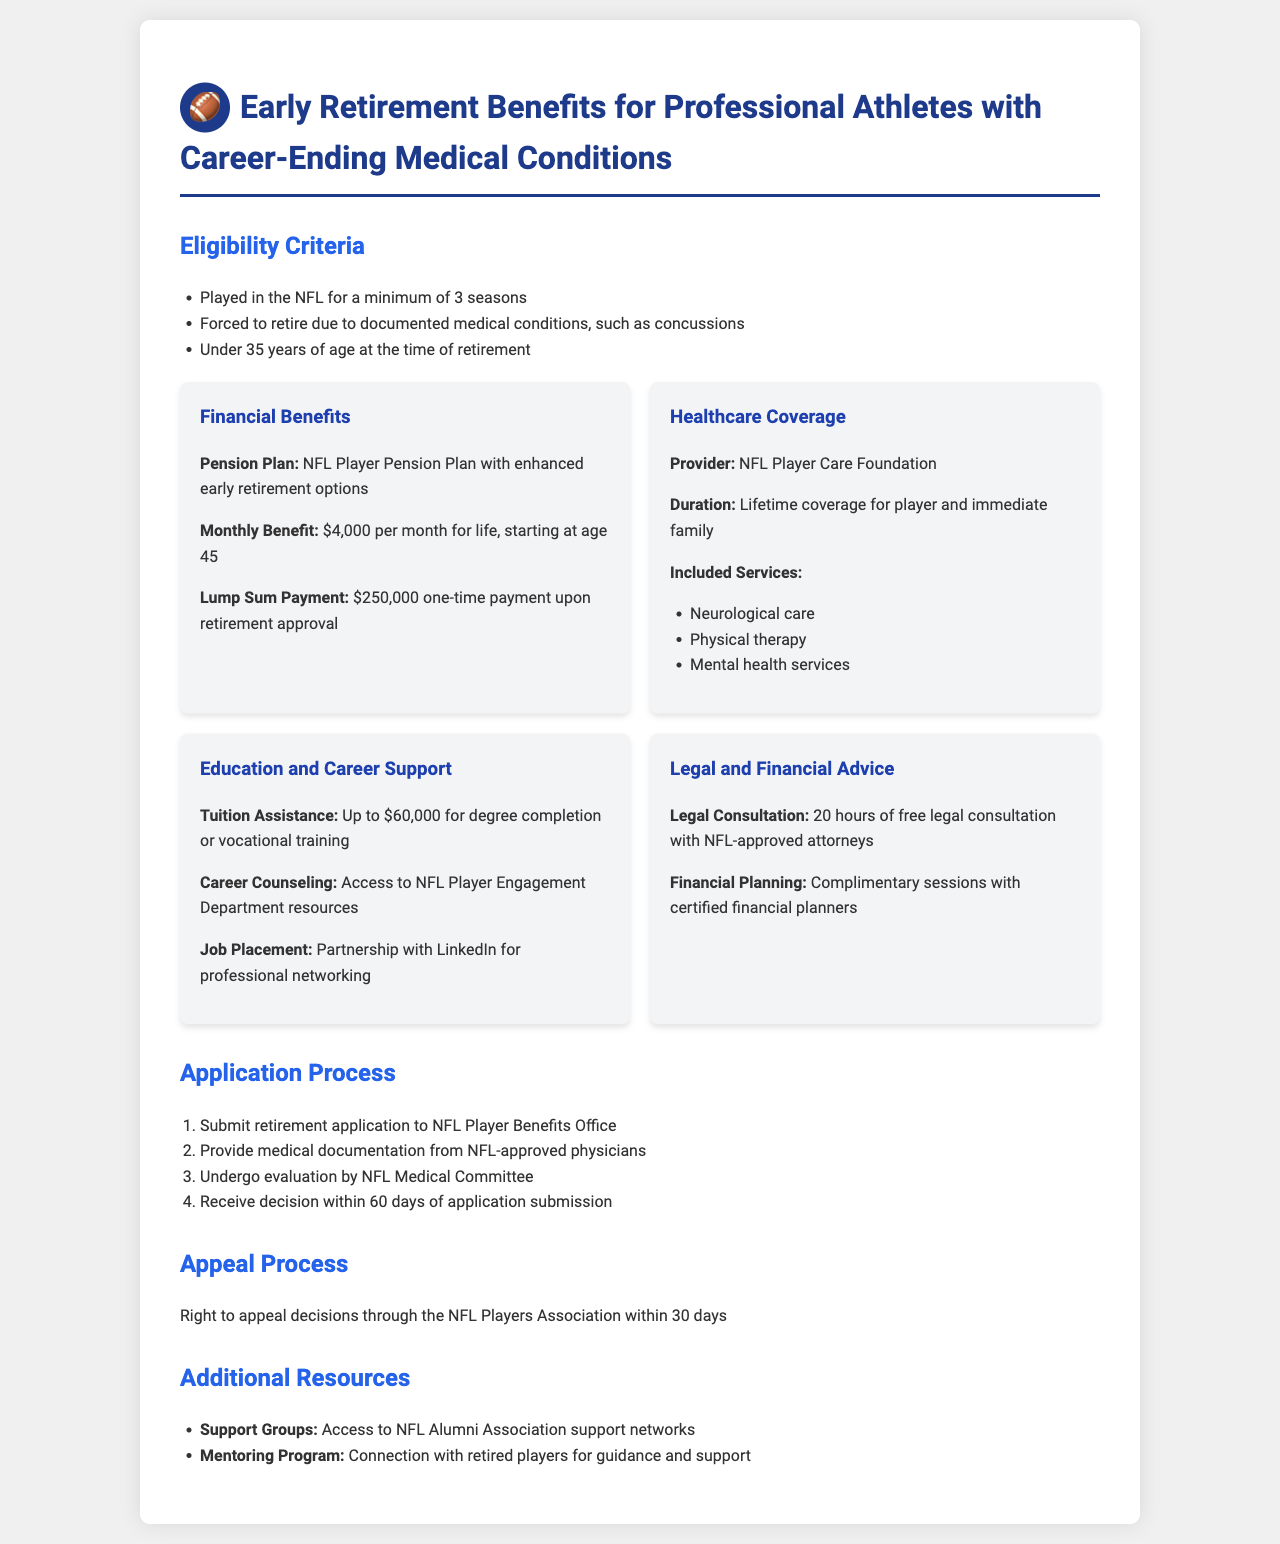What is the minimum number of seasons a player must have played in the NFL? The document states that a player must have played a minimum of 3 seasons to be eligible for retirement benefits.
Answer: 3 seasons What is the monthly benefit amount starting at age 45? The document specifies that the monthly benefit amount is $4,000 per month for life, starting at age 45.
Answer: $4,000 What is the duration of healthcare coverage provided? The document indicates that healthcare coverage is provided for the lifetime of the player and immediate family.
Answer: Lifetime How much tuition assistance is available for degree completion or vocational training? The document lists that tuition assistance is up to $60,000 for degree completion or vocational training.
Answer: $60,000 What is the time frame for receiving a decision on the retirement application? The document states that a decision will be received within 60 days of application submission.
Answer: 60 days What right do players have if their retirement application is denied? The document mentions that players have the right to appeal decisions through the NFL Players Association within 30 days.
Answer: Appeal How many hours of free legal consultation are provided? The document specifies that players are entitled to 20 hours of free legal consultation with NFL-approved attorneys.
Answer: 20 hours What organization provides the healthcare coverage? The document names the NFL Player Care Foundation as the provider of healthcare coverage.
Answer: NFL Player Care Foundation What type of support is available through the mentoring program? The document indicates that the mentoring program connects players with retired players for guidance and support.
Answer: Guidance and support 